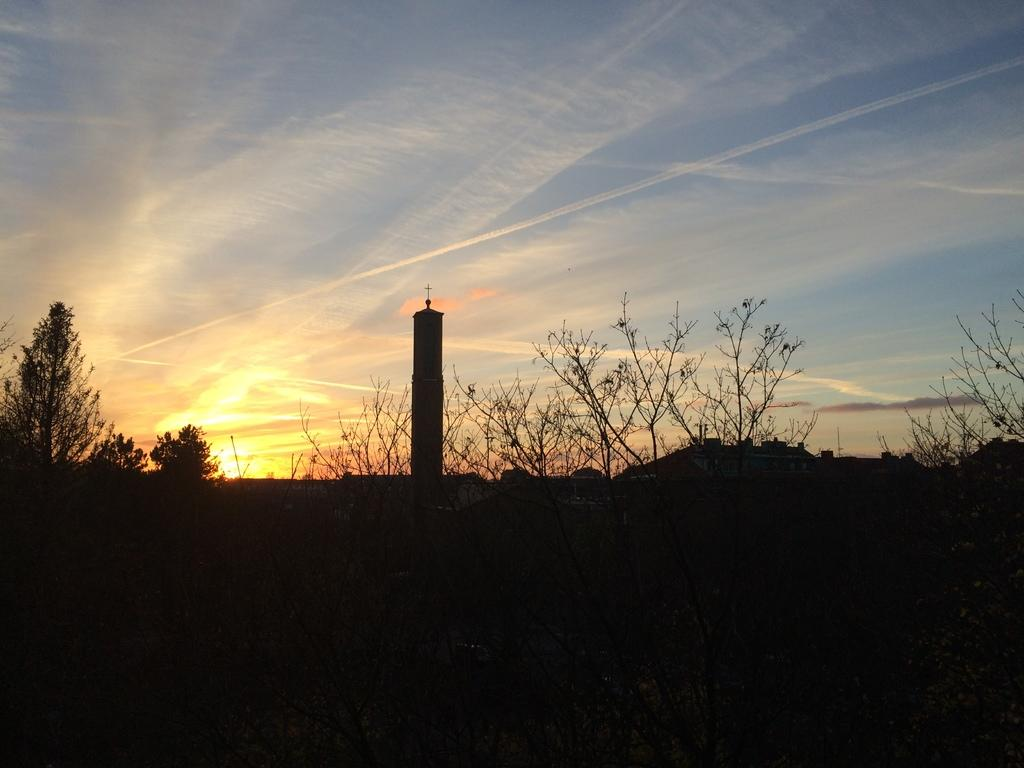What type of structures can be seen in the image? There are buildings in the image. What other natural elements are present in the image? There are trees in the image. What can be seen in the sky in the image? The sky is visible in the image, and clouds and the sun are present. Where is the lunch being served in the image? There is no mention of lunch or any food being served in the image. 